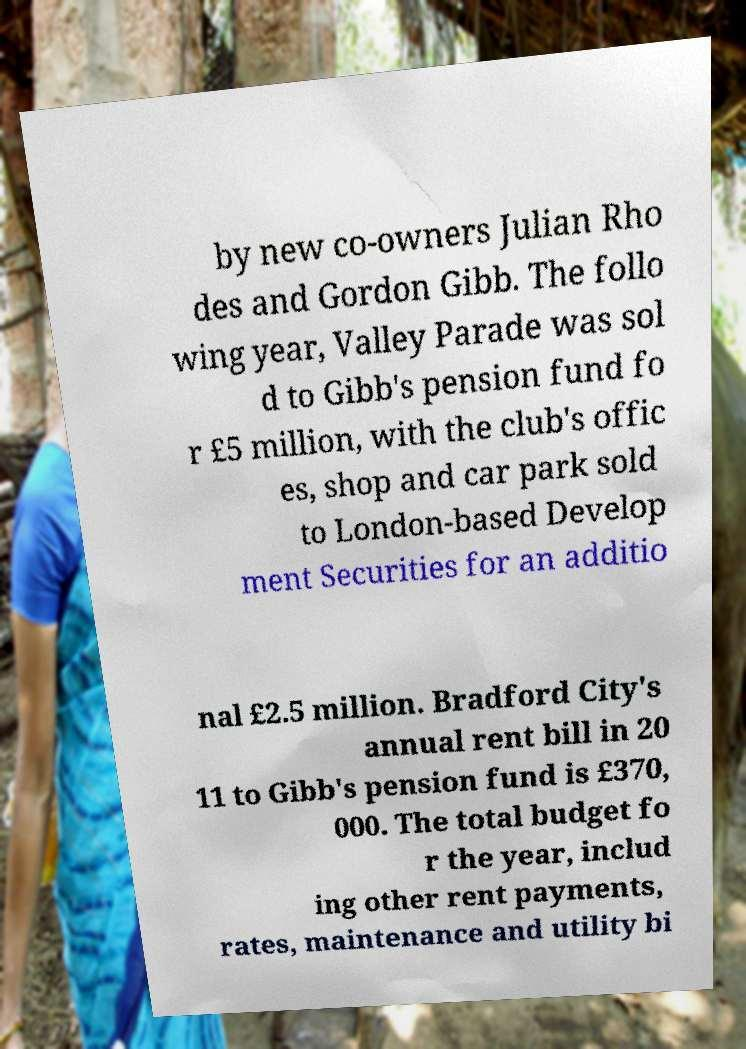Could you assist in decoding the text presented in this image and type it out clearly? by new co-owners Julian Rho des and Gordon Gibb. The follo wing year, Valley Parade was sol d to Gibb's pension fund fo r £5 million, with the club's offic es, shop and car park sold to London-based Develop ment Securities for an additio nal £2.5 million. Bradford City's annual rent bill in 20 11 to Gibb's pension fund is £370, 000. The total budget fo r the year, includ ing other rent payments, rates, maintenance and utility bi 